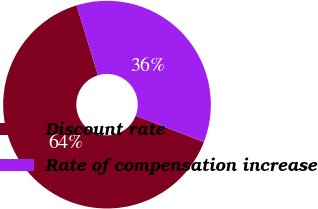Convert chart to OTSL. <chart><loc_0><loc_0><loc_500><loc_500><pie_chart><fcel>Discount rate<fcel>Rate of compensation increase<nl><fcel>64.41%<fcel>35.59%<nl></chart> 